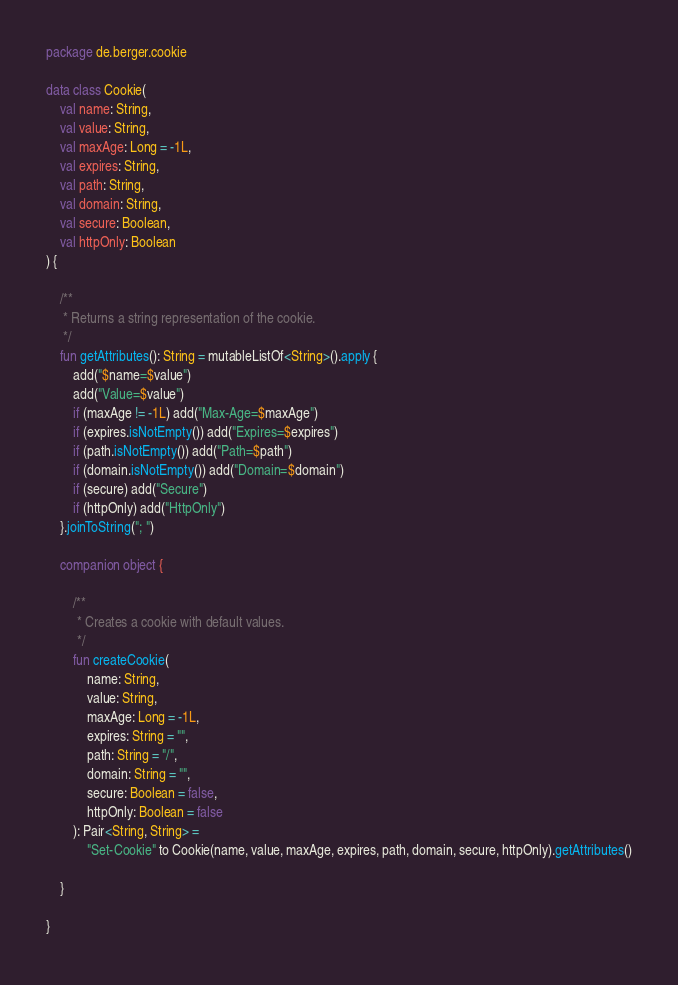Convert code to text. <code><loc_0><loc_0><loc_500><loc_500><_Kotlin_>package de.berger.cookie

data class Cookie(
    val name: String,
    val value: String,
    val maxAge: Long = -1L,
    val expires: String,
    val path: String,
    val domain: String,
    val secure: Boolean,
    val httpOnly: Boolean
) {

    /**
     * Returns a string representation of the cookie.
     */
    fun getAttributes(): String = mutableListOf<String>().apply {
        add("$name=$value")
        add("Value=$value")
        if (maxAge != -1L) add("Max-Age=$maxAge")
        if (expires.isNotEmpty()) add("Expires=$expires")
        if (path.isNotEmpty()) add("Path=$path")
        if (domain.isNotEmpty()) add("Domain=$domain")
        if (secure) add("Secure")
        if (httpOnly) add("HttpOnly")
    }.joinToString("; ")

    companion object {

        /**
         * Creates a cookie with default values.
         */
        fun createCookie(
            name: String,
            value: String,
            maxAge: Long = -1L,
            expires: String = "",
            path: String = "/",
            domain: String = "",
            secure: Boolean = false,
            httpOnly: Boolean = false
        ): Pair<String, String> =
            "Set-Cookie" to Cookie(name, value, maxAge, expires, path, domain, secure, httpOnly).getAttributes()

    }

}</code> 